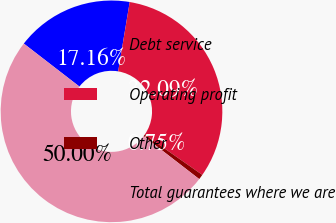Convert chart to OTSL. <chart><loc_0><loc_0><loc_500><loc_500><pie_chart><fcel>Debt service<fcel>Operating profit<fcel>Other<fcel>Total guarantees where we are<nl><fcel>17.16%<fcel>32.09%<fcel>0.75%<fcel>50.0%<nl></chart> 